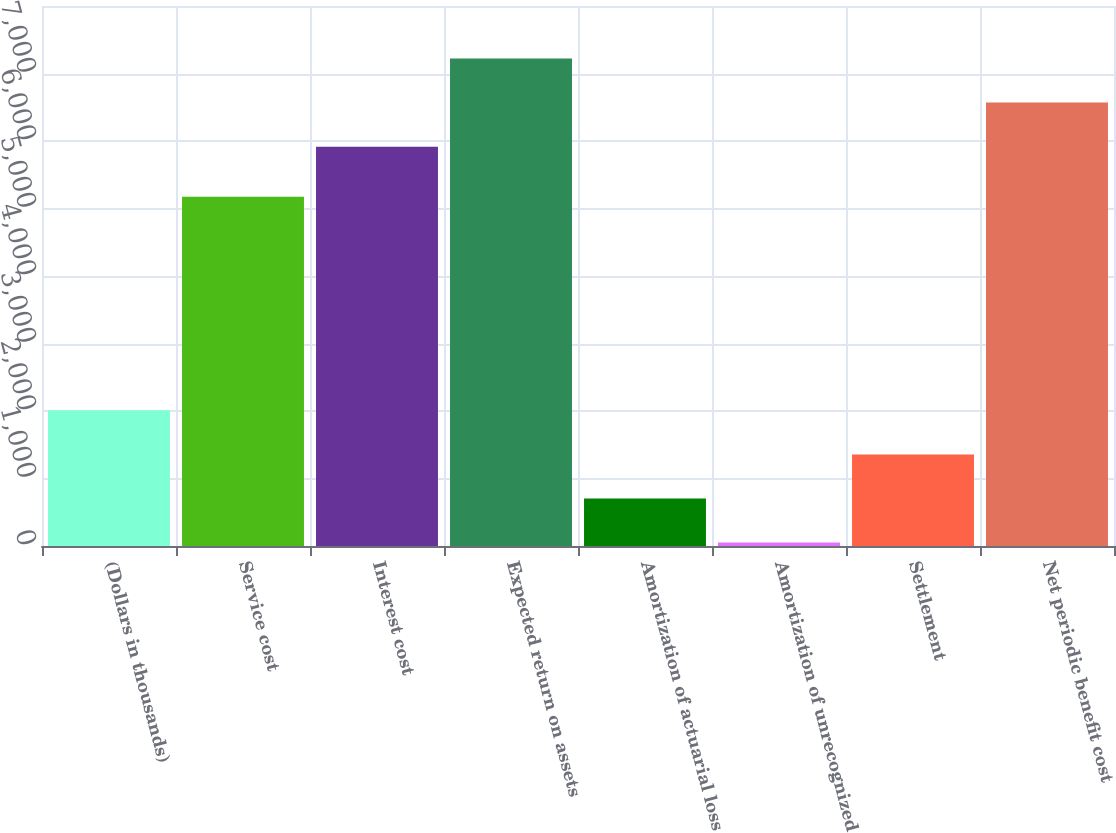Convert chart to OTSL. <chart><loc_0><loc_0><loc_500><loc_500><bar_chart><fcel>(Dollars in thousands)<fcel>Service cost<fcel>Interest cost<fcel>Expected return on assets<fcel>Amortization of actuarial loss<fcel>Amortization of unrecognized<fcel>Settlement<fcel>Net periodic benefit cost<nl><fcel>2010.6<fcel>5174<fcel>5916<fcel>7222.4<fcel>704.2<fcel>51<fcel>1357.4<fcel>6569.2<nl></chart> 